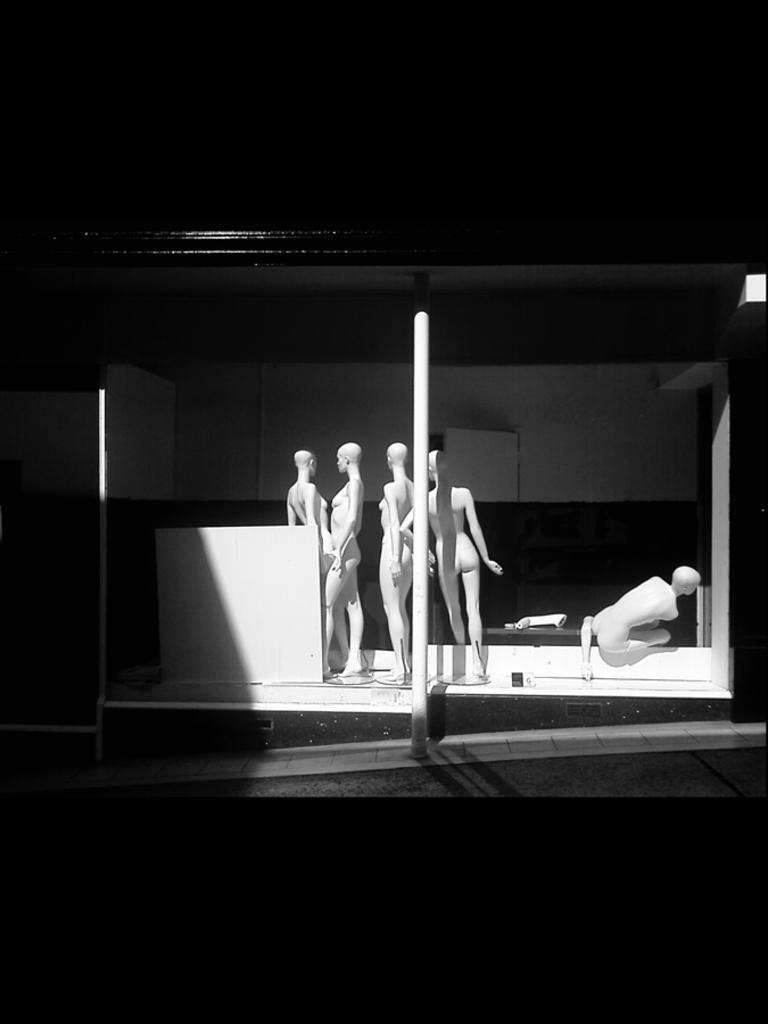What is the main subject of the image? There are depictions of people in the center of the image. What object can be seen in the image besides the people? There is a pole in the image. What can be seen in the background of the image? There is a wall in the background of the image. What type of animal can be seen in the wilderness in the image? There is no animal or wilderness present in the image; it features depictions of people and a pole with a wall in the background. 